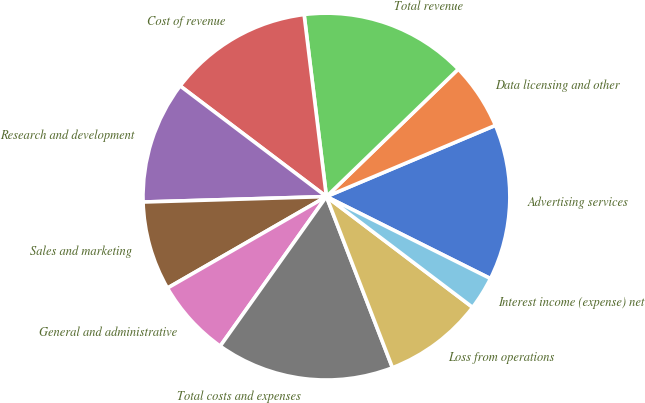<chart> <loc_0><loc_0><loc_500><loc_500><pie_chart><fcel>Advertising services<fcel>Data licensing and other<fcel>Total revenue<fcel>Cost of revenue<fcel>Research and development<fcel>Sales and marketing<fcel>General and administrative<fcel>Total costs and expenses<fcel>Loss from operations<fcel>Interest income (expense) net<nl><fcel>13.73%<fcel>5.88%<fcel>14.71%<fcel>12.75%<fcel>10.78%<fcel>7.84%<fcel>6.86%<fcel>15.69%<fcel>8.82%<fcel>2.94%<nl></chart> 